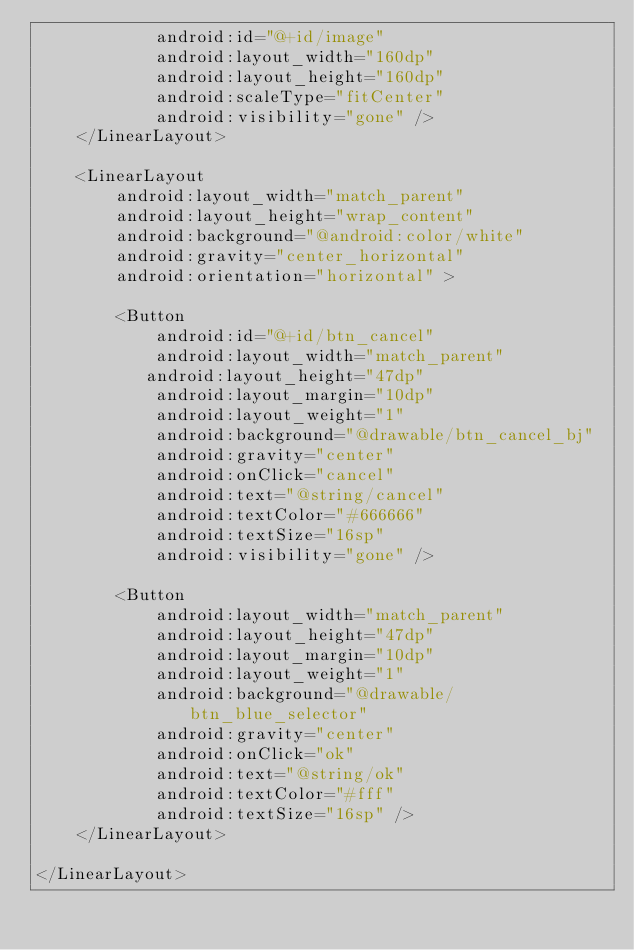Convert code to text. <code><loc_0><loc_0><loc_500><loc_500><_XML_>            android:id="@+id/image"
            android:layout_width="160dp"
            android:layout_height="160dp"
            android:scaleType="fitCenter"
            android:visibility="gone" />
    </LinearLayout>

    <LinearLayout
        android:layout_width="match_parent"
        android:layout_height="wrap_content"
        android:background="@android:color/white"
        android:gravity="center_horizontal"
        android:orientation="horizontal" >

        <Button
            android:id="@+id/btn_cancel"
            android:layout_width="match_parent"
           android:layout_height="47dp"
            android:layout_margin="10dp"
            android:layout_weight="1"
            android:background="@drawable/btn_cancel_bj"
            android:gravity="center"
            android:onClick="cancel"
            android:text="@string/cancel"
            android:textColor="#666666"
            android:textSize="16sp"
            android:visibility="gone" />

        <Button
            android:layout_width="match_parent"
            android:layout_height="47dp"
            android:layout_margin="10dp"
            android:layout_weight="1"
            android:background="@drawable/btn_blue_selector"
            android:gravity="center"
            android:onClick="ok"
            android:text="@string/ok"
            android:textColor="#fff"
            android:textSize="16sp" />
    </LinearLayout>

</LinearLayout>
</code> 